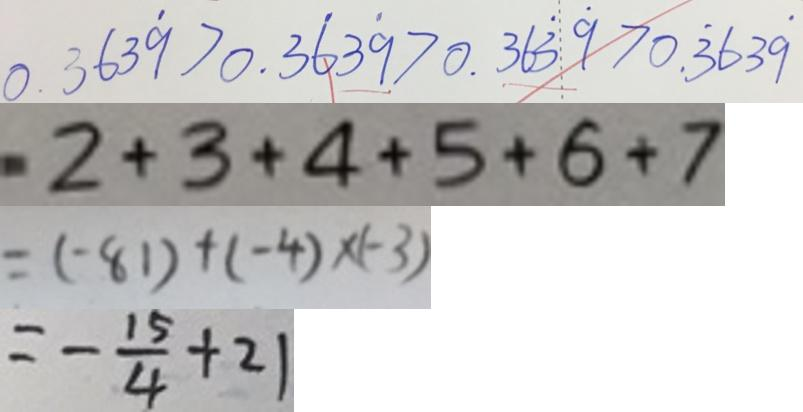Convert formula to latex. <formula><loc_0><loc_0><loc_500><loc_500>0 . 3 6 3 \dot { 9 } > 0 . 3 \dot { 6 } 3 \dot { 9 } > 0 . 3 6 \dot { 3 } \dot { 9 } > 0 . \dot { 3 } 6 3 \dot { 9 } 
 2 + 3 + 4 + 5 + 6 + 7 
 = ( - 8 1 ) + ( - 4 ) \times ( - 3 ) 
 = - \frac { 1 5 } { 4 } + 2 1</formula> 